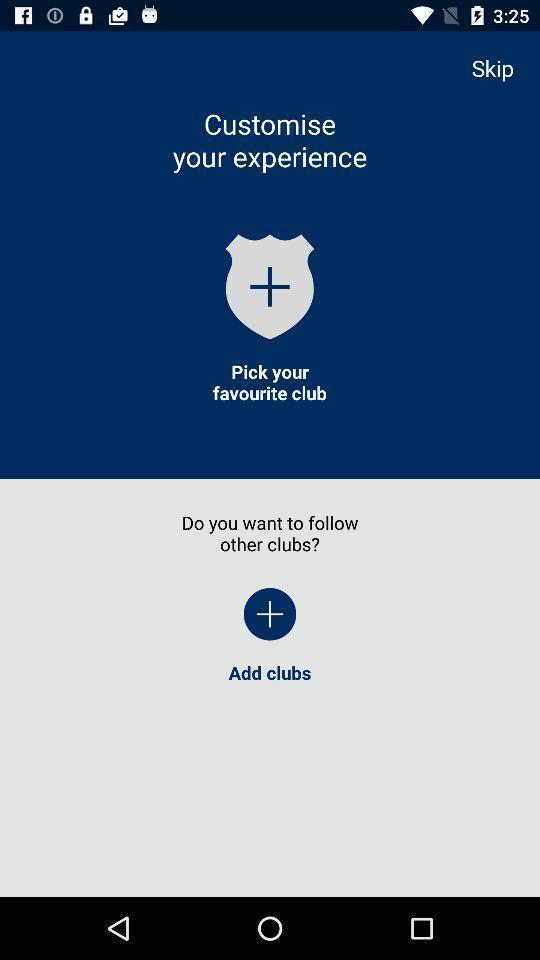Give me a summary of this screen capture. Screen displaying information about application. 